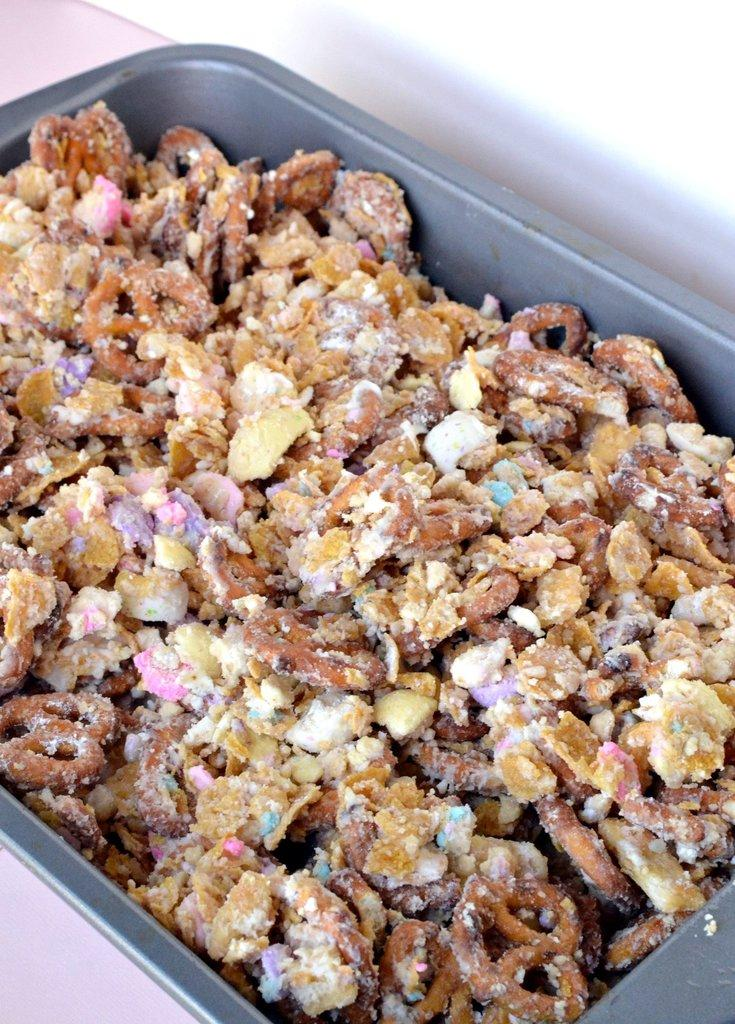What is present in the image? There is food in the image. How is the food arranged or contained? The food is in a metal tray. How long does it take for the food to burn in the image? There is no indication of the food burning in the image, so it cannot be determined from the image. 